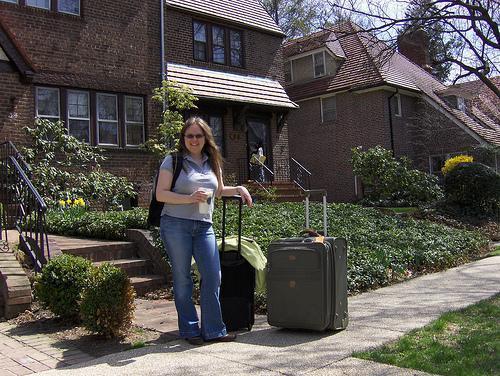How many travel cases are there?
Give a very brief answer. 2. How many purses are there?
Give a very brief answer. 1. 